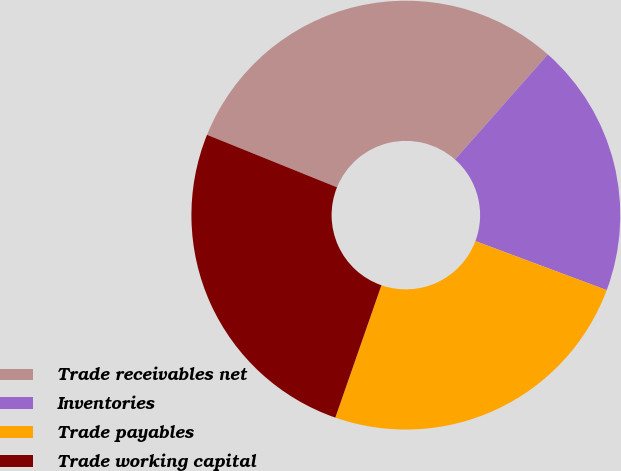Convert chart to OTSL. <chart><loc_0><loc_0><loc_500><loc_500><pie_chart><fcel>Trade receivables net<fcel>Inventories<fcel>Trade payables<fcel>Trade working capital<nl><fcel>30.41%<fcel>19.17%<fcel>24.65%<fcel>25.78%<nl></chart> 